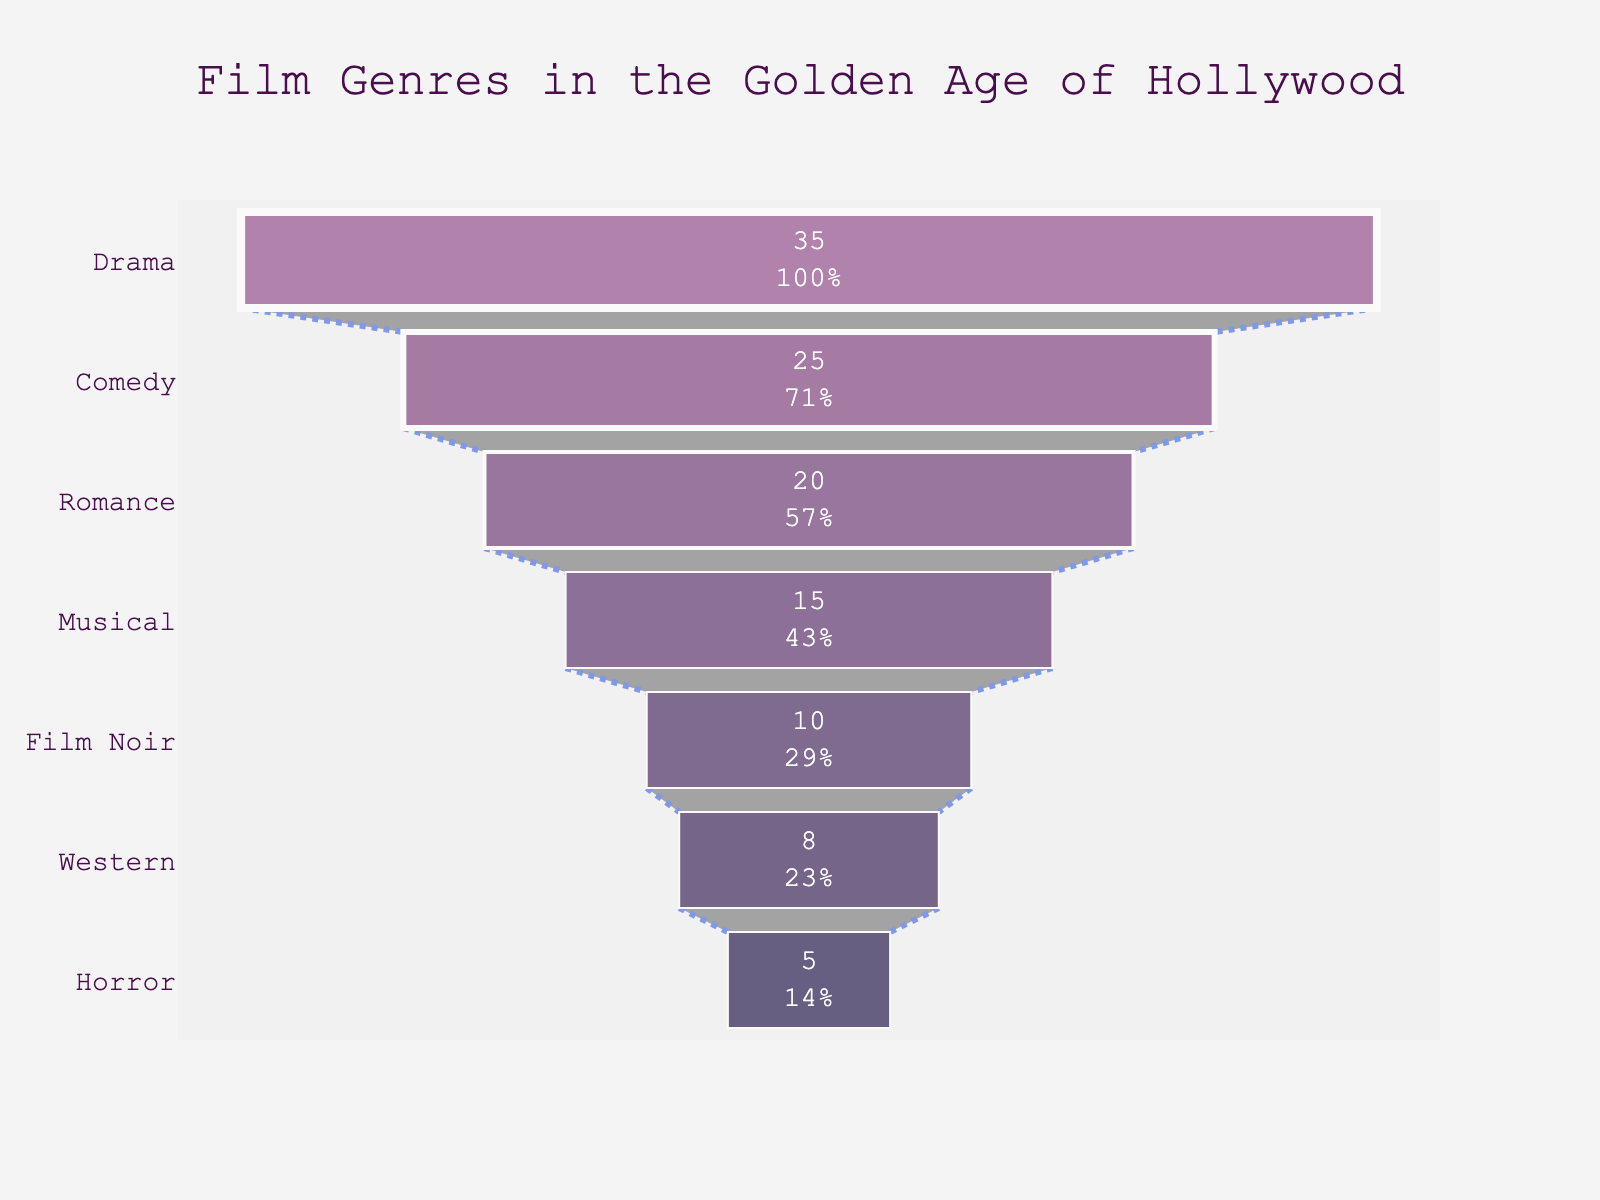How many genres are represented in the funnel chart? Count the number of unique entries in the genre list.
Answer: 7 Which genre holds the highest percentage? Look for the funnel section with the largest width or the highest value.
Answer: Drama What is the combined percentage of Horror and Western genres? Add the percentages of Horror (5%) and Western (8%). 5 + 8 = 13
Answer: 13% Is the percentage of Comedy greater than that of Romance? Compare the percentage values of Comedy (25%) and Romance (20%).
Answer: Yes What is the difference in percentage between the Musical and Film Noir genres? Subtract the percentage of Film Noir (10%) from the percentage of Musical (15%). 15 - 10 = 5
Answer: 5% Among the genres, which one is at the very bottom? Identify the genre at the bottom part of the funnel.
Answer: Horror Which two genres together make up exactly 30% of the total distribution? Find combinations of genres whose percentages sum up to 30. 15 (Musical) + 15 (Musical) = 30
Answer: Musical and Musical What is the percentage range covered by the chart? Subtract the smallest percentage (Horror, 5%) from the largest percentage (Drama, 35%). 35 - 5 = 30
Answer: 30% Between Musical and Film Noir, which genre's percentage could fit into Drama's remaining percentage after subtracting Comedy's percentage? Calculate Drama's remaining percentage after Comedy. 35 - 25 = 10. Compare 10 with Musical (15) and Film Noir (10).
Answer: Film Noir What is the title of the funnel chart? Read the title text from the top section of the chart.
Answer: Film Genres in the Golden Age of Hollywood 